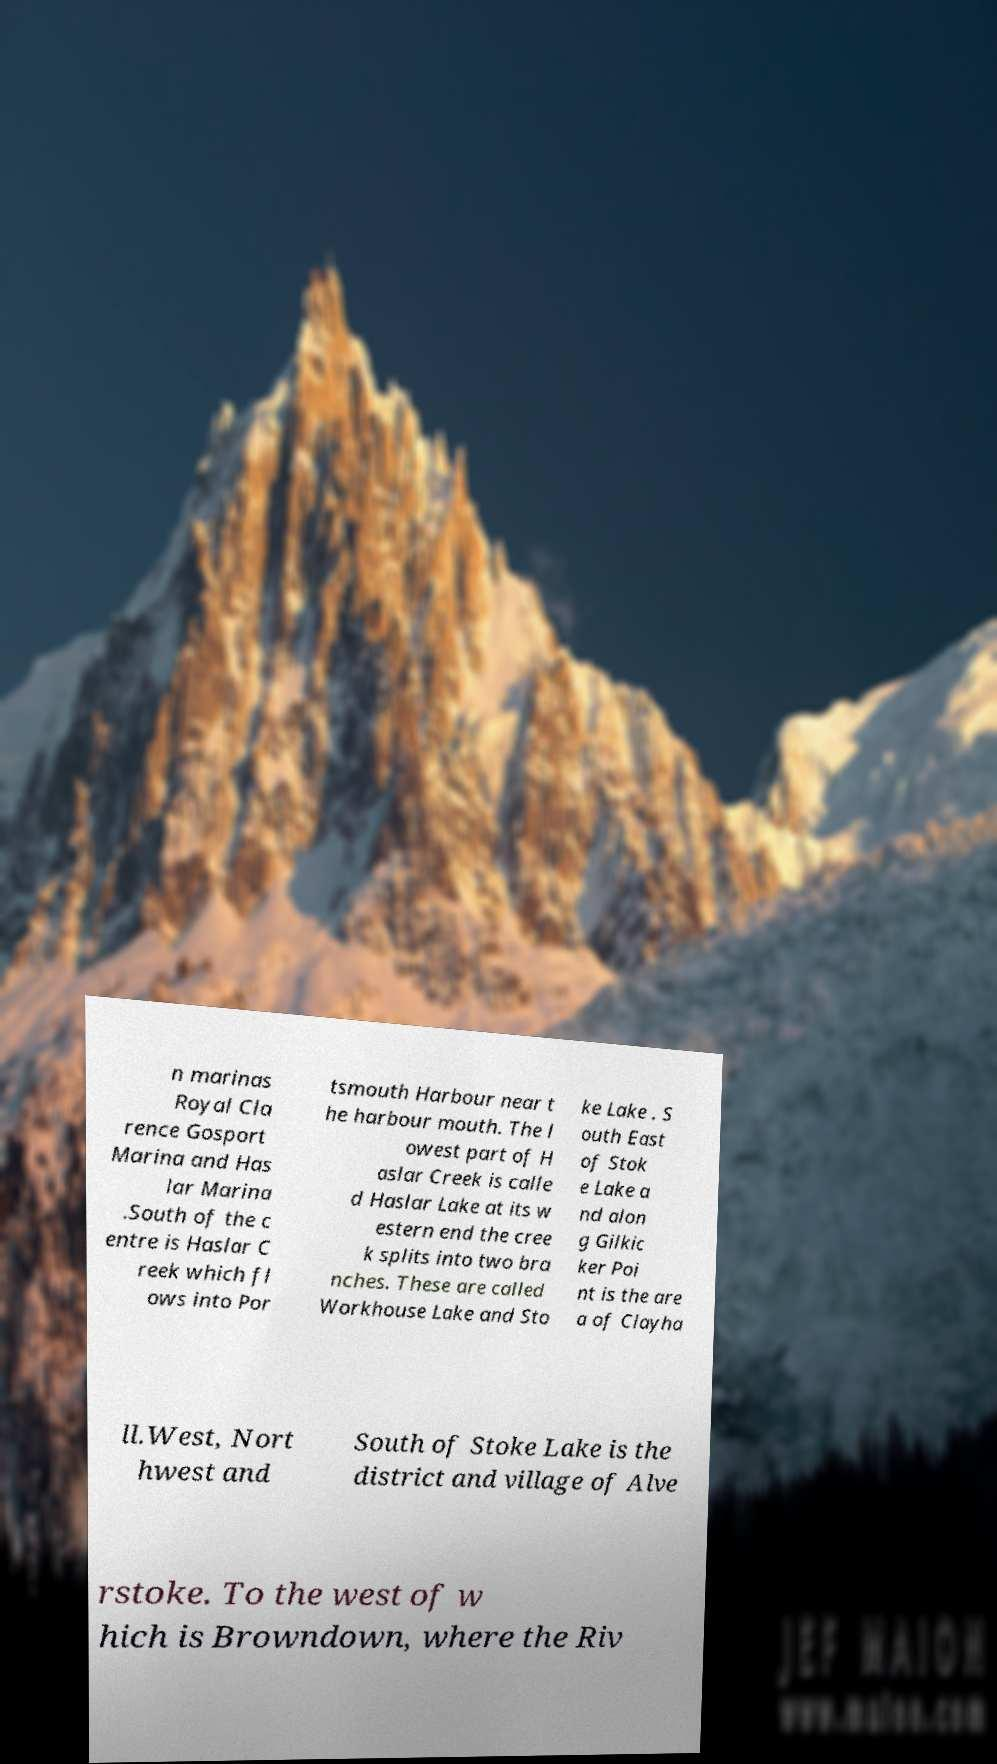Could you extract and type out the text from this image? n marinas Royal Cla rence Gosport Marina and Has lar Marina .South of the c entre is Haslar C reek which fl ows into Por tsmouth Harbour near t he harbour mouth. The l owest part of H aslar Creek is calle d Haslar Lake at its w estern end the cree k splits into two bra nches. These are called Workhouse Lake and Sto ke Lake . S outh East of Stok e Lake a nd alon g Gilkic ker Poi nt is the are a of Clayha ll.West, Nort hwest and South of Stoke Lake is the district and village of Alve rstoke. To the west of w hich is Browndown, where the Riv 